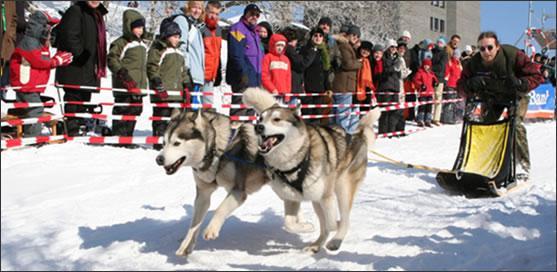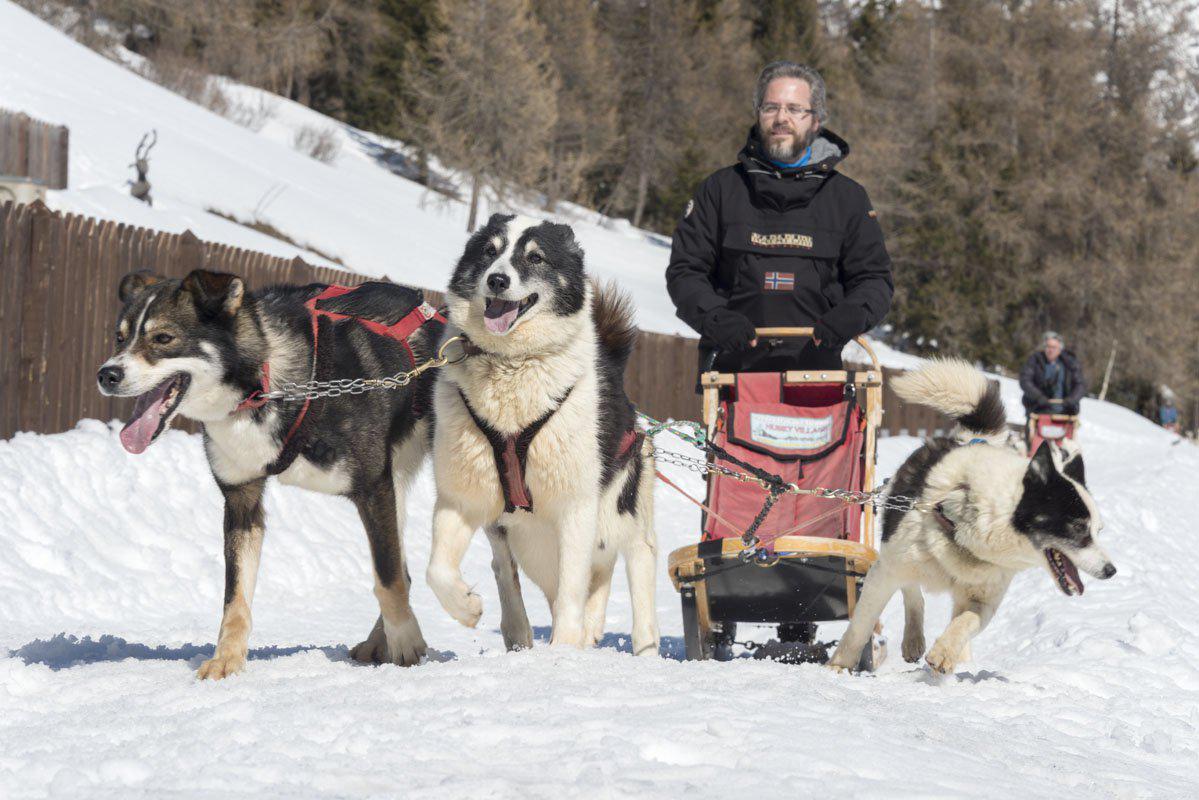The first image is the image on the left, the second image is the image on the right. Given the left and right images, does the statement "One of the images shows exactly two dogs pulling the sled." hold true? Answer yes or no. Yes. The first image is the image on the left, the second image is the image on the right. Considering the images on both sides, is "A crowd of people stand packed together on the left to watch a sled dog race, in one image." valid? Answer yes or no. Yes. 